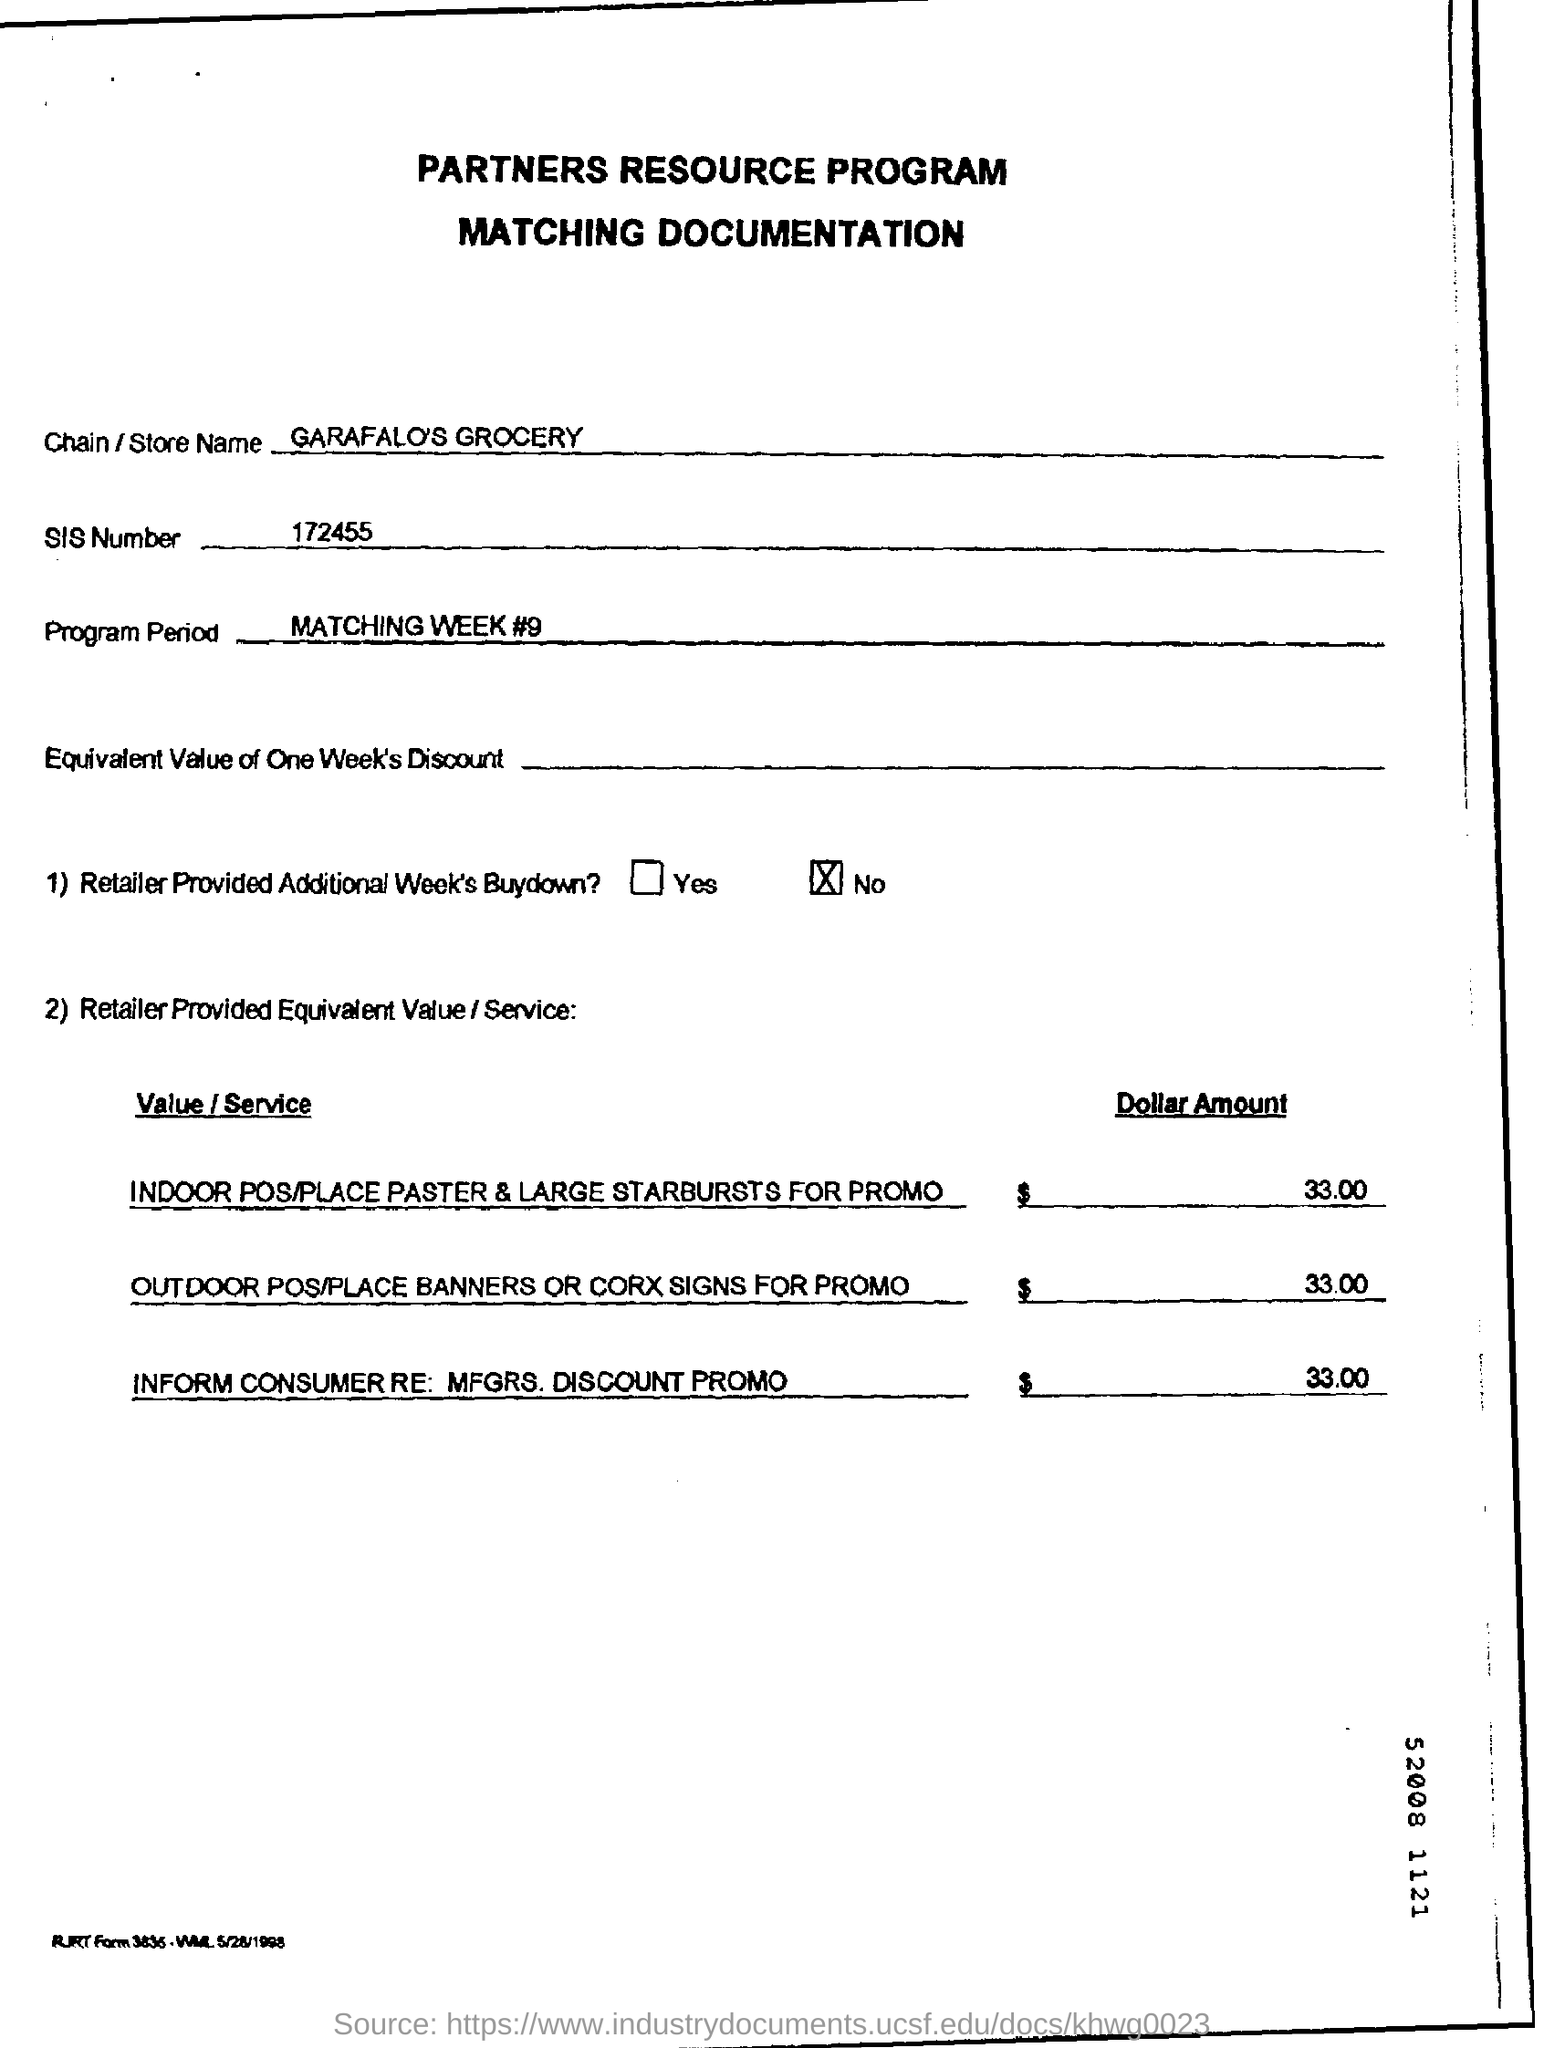Draw attention to some important aspects in this diagram. The dollar amount mentioned in the document is 33.00. The documentation mentions the store name as Garafalo's Grocery. The SIS number is 172455. 